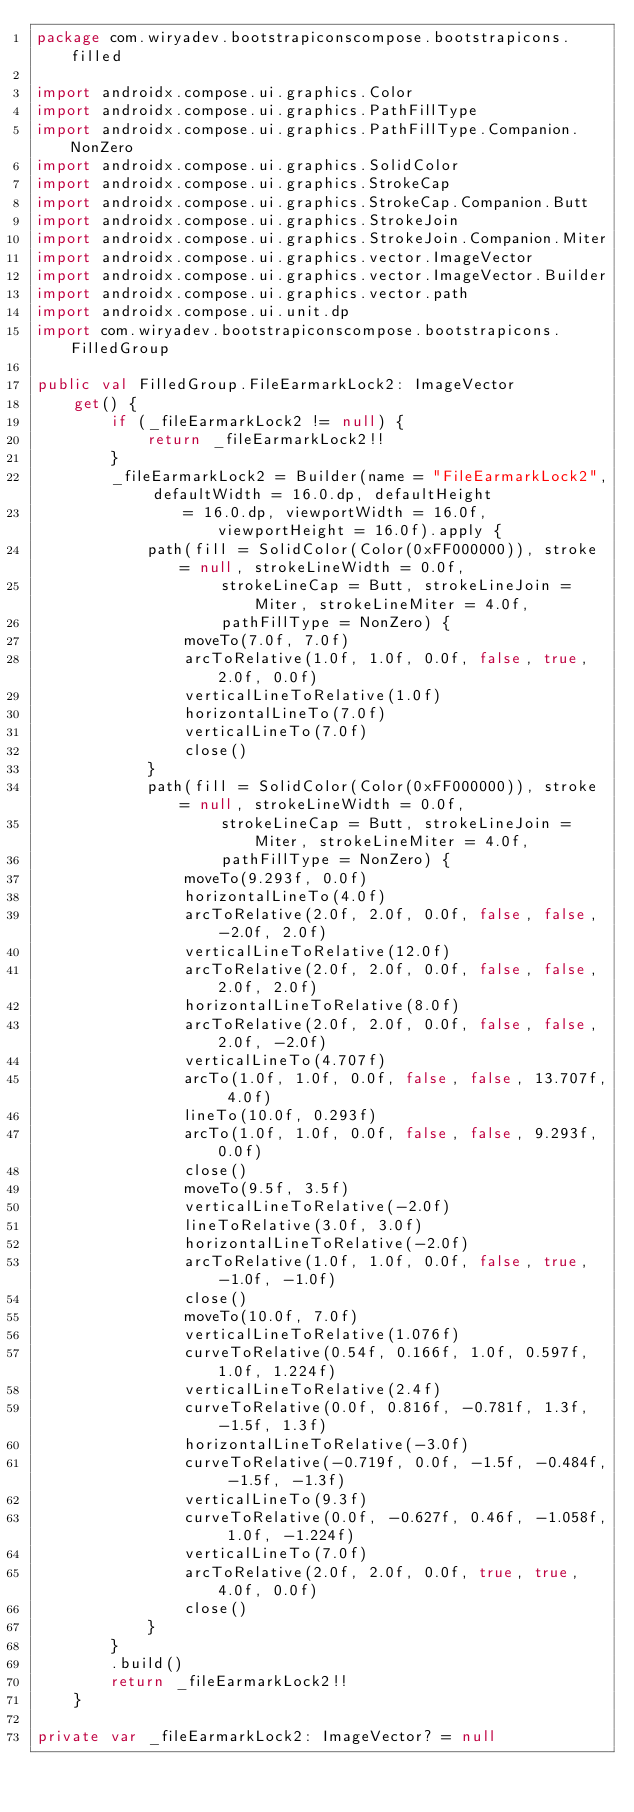Convert code to text. <code><loc_0><loc_0><loc_500><loc_500><_Kotlin_>package com.wiryadev.bootstrapiconscompose.bootstrapicons.filled

import androidx.compose.ui.graphics.Color
import androidx.compose.ui.graphics.PathFillType
import androidx.compose.ui.graphics.PathFillType.Companion.NonZero
import androidx.compose.ui.graphics.SolidColor
import androidx.compose.ui.graphics.StrokeCap
import androidx.compose.ui.graphics.StrokeCap.Companion.Butt
import androidx.compose.ui.graphics.StrokeJoin
import androidx.compose.ui.graphics.StrokeJoin.Companion.Miter
import androidx.compose.ui.graphics.vector.ImageVector
import androidx.compose.ui.graphics.vector.ImageVector.Builder
import androidx.compose.ui.graphics.vector.path
import androidx.compose.ui.unit.dp
import com.wiryadev.bootstrapiconscompose.bootstrapicons.FilledGroup

public val FilledGroup.FileEarmarkLock2: ImageVector
    get() {
        if (_fileEarmarkLock2 != null) {
            return _fileEarmarkLock2!!
        }
        _fileEarmarkLock2 = Builder(name = "FileEarmarkLock2", defaultWidth = 16.0.dp, defaultHeight
                = 16.0.dp, viewportWidth = 16.0f, viewportHeight = 16.0f).apply {
            path(fill = SolidColor(Color(0xFF000000)), stroke = null, strokeLineWidth = 0.0f,
                    strokeLineCap = Butt, strokeLineJoin = Miter, strokeLineMiter = 4.0f,
                    pathFillType = NonZero) {
                moveTo(7.0f, 7.0f)
                arcToRelative(1.0f, 1.0f, 0.0f, false, true, 2.0f, 0.0f)
                verticalLineToRelative(1.0f)
                horizontalLineTo(7.0f)
                verticalLineTo(7.0f)
                close()
            }
            path(fill = SolidColor(Color(0xFF000000)), stroke = null, strokeLineWidth = 0.0f,
                    strokeLineCap = Butt, strokeLineJoin = Miter, strokeLineMiter = 4.0f,
                    pathFillType = NonZero) {
                moveTo(9.293f, 0.0f)
                horizontalLineTo(4.0f)
                arcToRelative(2.0f, 2.0f, 0.0f, false, false, -2.0f, 2.0f)
                verticalLineToRelative(12.0f)
                arcToRelative(2.0f, 2.0f, 0.0f, false, false, 2.0f, 2.0f)
                horizontalLineToRelative(8.0f)
                arcToRelative(2.0f, 2.0f, 0.0f, false, false, 2.0f, -2.0f)
                verticalLineTo(4.707f)
                arcTo(1.0f, 1.0f, 0.0f, false, false, 13.707f, 4.0f)
                lineTo(10.0f, 0.293f)
                arcTo(1.0f, 1.0f, 0.0f, false, false, 9.293f, 0.0f)
                close()
                moveTo(9.5f, 3.5f)
                verticalLineToRelative(-2.0f)
                lineToRelative(3.0f, 3.0f)
                horizontalLineToRelative(-2.0f)
                arcToRelative(1.0f, 1.0f, 0.0f, false, true, -1.0f, -1.0f)
                close()
                moveTo(10.0f, 7.0f)
                verticalLineToRelative(1.076f)
                curveToRelative(0.54f, 0.166f, 1.0f, 0.597f, 1.0f, 1.224f)
                verticalLineToRelative(2.4f)
                curveToRelative(0.0f, 0.816f, -0.781f, 1.3f, -1.5f, 1.3f)
                horizontalLineToRelative(-3.0f)
                curveToRelative(-0.719f, 0.0f, -1.5f, -0.484f, -1.5f, -1.3f)
                verticalLineTo(9.3f)
                curveToRelative(0.0f, -0.627f, 0.46f, -1.058f, 1.0f, -1.224f)
                verticalLineTo(7.0f)
                arcToRelative(2.0f, 2.0f, 0.0f, true, true, 4.0f, 0.0f)
                close()
            }
        }
        .build()
        return _fileEarmarkLock2!!
    }

private var _fileEarmarkLock2: ImageVector? = null
</code> 